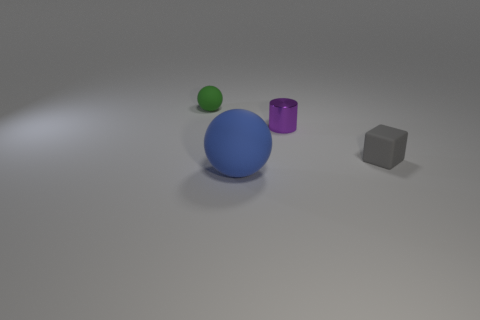Add 3 purple metal objects. How many objects exist? 7 Subtract all blocks. How many objects are left? 3 Subtract all tiny purple metallic things. Subtract all tiny metal cylinders. How many objects are left? 2 Add 1 purple metallic objects. How many purple metallic objects are left? 2 Add 4 big brown metallic things. How many big brown metallic things exist? 4 Subtract 0 red spheres. How many objects are left? 4 